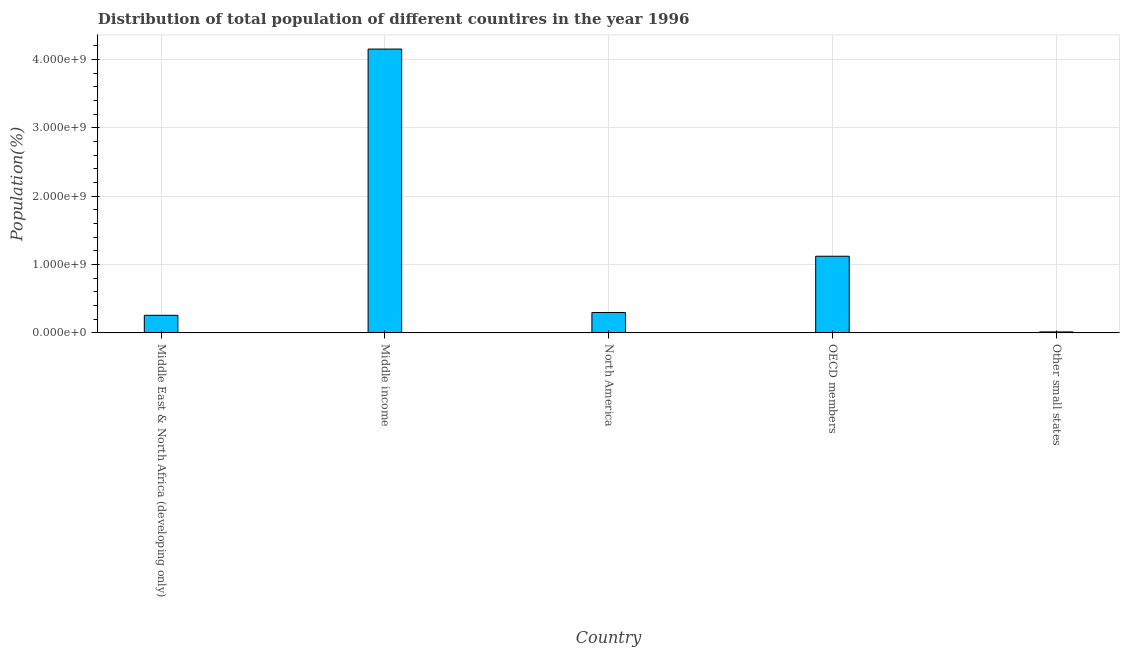Does the graph contain grids?
Give a very brief answer. Yes. What is the title of the graph?
Offer a terse response. Distribution of total population of different countires in the year 1996. What is the label or title of the X-axis?
Keep it short and to the point. Country. What is the label or title of the Y-axis?
Give a very brief answer. Population(%). What is the population in Middle income?
Ensure brevity in your answer.  4.15e+09. Across all countries, what is the maximum population?
Your answer should be compact. 4.15e+09. Across all countries, what is the minimum population?
Your response must be concise. 1.51e+07. In which country was the population maximum?
Your answer should be compact. Middle income. In which country was the population minimum?
Your answer should be compact. Other small states. What is the sum of the population?
Keep it short and to the point. 5.85e+09. What is the difference between the population in Middle income and North America?
Offer a terse response. 3.85e+09. What is the average population per country?
Your response must be concise. 1.17e+09. What is the median population?
Offer a very short reply. 2.99e+08. In how many countries, is the population greater than 3600000000 %?
Make the answer very short. 1. What is the ratio of the population in North America to that in Other small states?
Your response must be concise. 19.8. Is the difference between the population in Middle income and OECD members greater than the difference between any two countries?
Your answer should be very brief. No. What is the difference between the highest and the second highest population?
Keep it short and to the point. 3.03e+09. What is the difference between the highest and the lowest population?
Ensure brevity in your answer.  4.14e+09. In how many countries, is the population greater than the average population taken over all countries?
Your response must be concise. 1. How many countries are there in the graph?
Offer a very short reply. 5. What is the difference between two consecutive major ticks on the Y-axis?
Your response must be concise. 1.00e+09. Are the values on the major ticks of Y-axis written in scientific E-notation?
Keep it short and to the point. Yes. What is the Population(%) in Middle East & North Africa (developing only)?
Provide a short and direct response. 2.58e+08. What is the Population(%) in Middle income?
Make the answer very short. 4.15e+09. What is the Population(%) in North America?
Your answer should be compact. 2.99e+08. What is the Population(%) in OECD members?
Your answer should be compact. 1.12e+09. What is the Population(%) of Other small states?
Keep it short and to the point. 1.51e+07. What is the difference between the Population(%) in Middle East & North Africa (developing only) and Middle income?
Ensure brevity in your answer.  -3.89e+09. What is the difference between the Population(%) in Middle East & North Africa (developing only) and North America?
Provide a short and direct response. -4.11e+07. What is the difference between the Population(%) in Middle East & North Africa (developing only) and OECD members?
Ensure brevity in your answer.  -8.64e+08. What is the difference between the Population(%) in Middle East & North Africa (developing only) and Other small states?
Ensure brevity in your answer.  2.43e+08. What is the difference between the Population(%) in Middle income and North America?
Ensure brevity in your answer.  3.85e+09. What is the difference between the Population(%) in Middle income and OECD members?
Offer a very short reply. 3.03e+09. What is the difference between the Population(%) in Middle income and Other small states?
Your answer should be compact. 4.14e+09. What is the difference between the Population(%) in North America and OECD members?
Keep it short and to the point. -8.23e+08. What is the difference between the Population(%) in North America and Other small states?
Provide a succinct answer. 2.84e+08. What is the difference between the Population(%) in OECD members and Other small states?
Provide a short and direct response. 1.11e+09. What is the ratio of the Population(%) in Middle East & North Africa (developing only) to that in Middle income?
Your response must be concise. 0.06. What is the ratio of the Population(%) in Middle East & North Africa (developing only) to that in North America?
Give a very brief answer. 0.86. What is the ratio of the Population(%) in Middle East & North Africa (developing only) to that in OECD members?
Keep it short and to the point. 0.23. What is the ratio of the Population(%) in Middle East & North Africa (developing only) to that in Other small states?
Make the answer very short. 17.08. What is the ratio of the Population(%) in Middle income to that in North America?
Make the answer very short. 13.88. What is the ratio of the Population(%) in Middle income to that in OECD members?
Provide a succinct answer. 3.7. What is the ratio of the Population(%) in Middle income to that in Other small states?
Give a very brief answer. 274.81. What is the ratio of the Population(%) in North America to that in OECD members?
Make the answer very short. 0.27. What is the ratio of the Population(%) in North America to that in Other small states?
Your answer should be very brief. 19.8. What is the ratio of the Population(%) in OECD members to that in Other small states?
Your answer should be very brief. 74.25. 